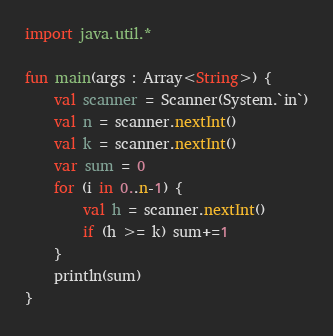<code> <loc_0><loc_0><loc_500><loc_500><_Kotlin_>import java.util.*

fun main(args : Array<String>) {
    val scanner = Scanner(System.`in`)
    val n = scanner.nextInt()
    val k = scanner.nextInt()
    var sum = 0
    for (i in 0..n-1) {
        val h = scanner.nextInt()
        if (h >= k) sum+=1
    }
    println(sum)
}
</code> 